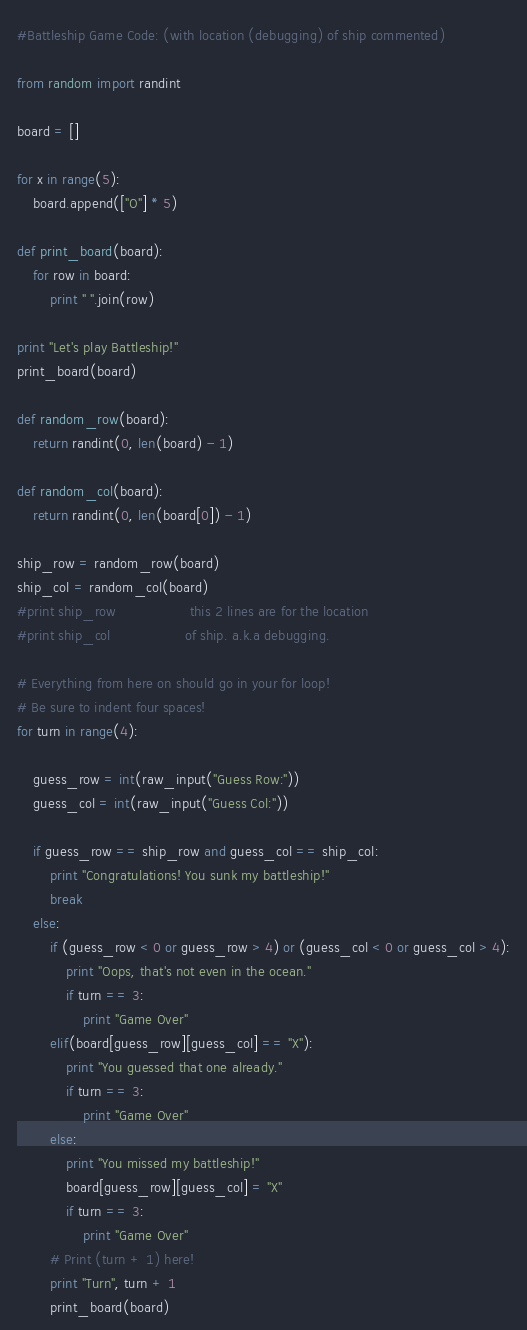Convert code to text. <code><loc_0><loc_0><loc_500><loc_500><_Python_>#Battleship Game Code: (with location (debugging) of ship commented)

from random import randint

board = []

for x in range(5):
    board.append(["O"] * 5)

def print_board(board):
    for row in board:
        print " ".join(row)

print "Let's play Battleship!"
print_board(board)

def random_row(board):
    return randint(0, len(board) - 1)

def random_col(board):
    return randint(0, len(board[0]) - 1)

ship_row = random_row(board)
ship_col = random_col(board)
#print ship_row                  this 2 lines are for the location
#print ship_col                  of ship. a.k.a debugging.

# Everything from here on should go in your for loop!
# Be sure to indent four spaces!
for turn in range(4):

    guess_row = int(raw_input("Guess Row:"))
    guess_col = int(raw_input("Guess Col:"))

    if guess_row == ship_row and guess_col == ship_col:
        print "Congratulations! You sunk my battleship!"
        break
    else:
        if (guess_row < 0 or guess_row > 4) or (guess_col < 0 or guess_col > 4):
            print "Oops, that's not even in the ocean."
            if turn == 3:
                print "Game Over"
        elif(board[guess_row][guess_col] == "X"):
            print "You guessed that one already."
            if turn == 3:
                print "Game Over"
        else:
            print "You missed my battleship!"
            board[guess_row][guess_col] = "X"
            if turn == 3:
                print "Game Over"
        # Print (turn + 1) here!
        print "Turn", turn + 1
        print_board(board)
</code> 